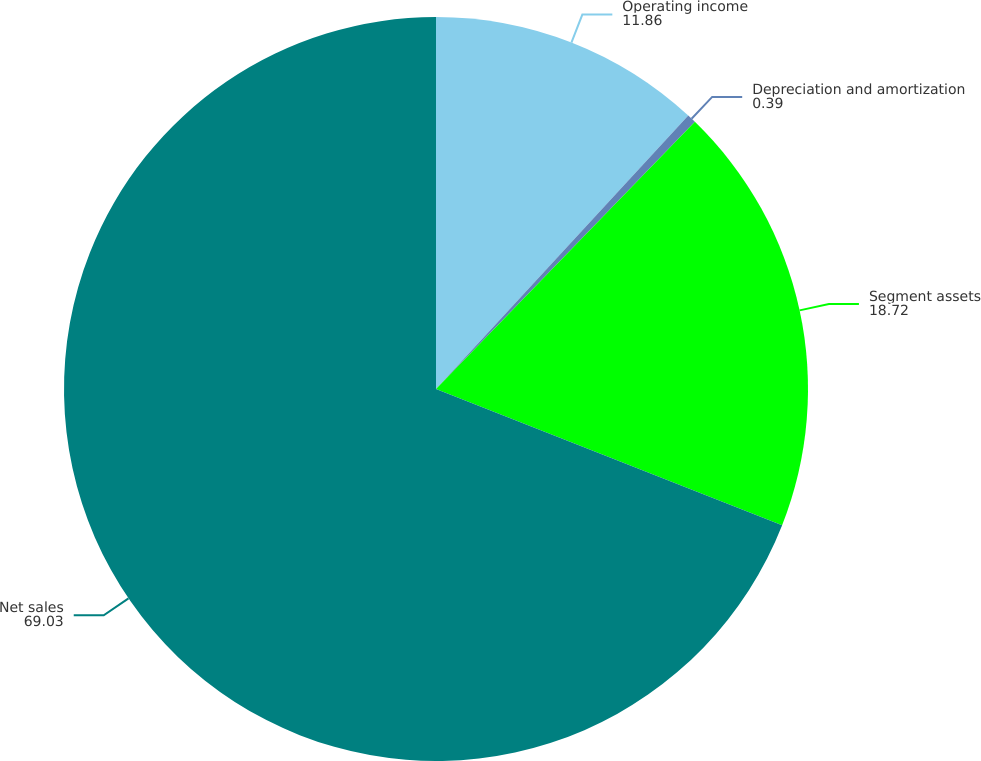Convert chart. <chart><loc_0><loc_0><loc_500><loc_500><pie_chart><fcel>Operating income<fcel>Depreciation and amortization<fcel>Segment assets<fcel>Net sales<nl><fcel>11.86%<fcel>0.39%<fcel>18.72%<fcel>69.03%<nl></chart> 